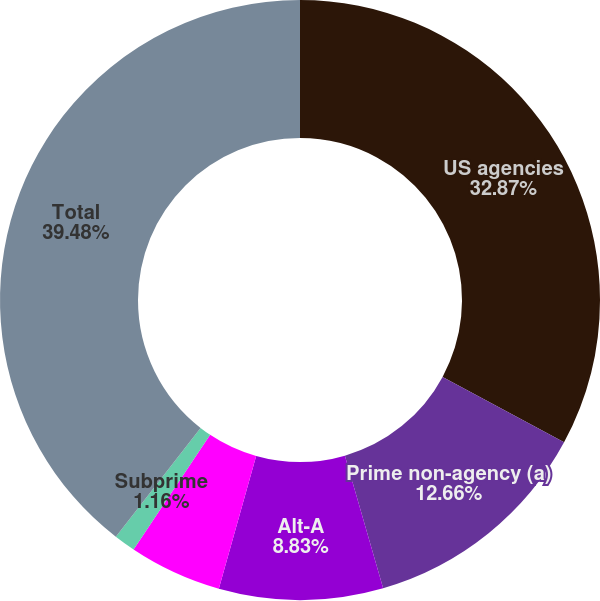Convert chart. <chart><loc_0><loc_0><loc_500><loc_500><pie_chart><fcel>US agencies<fcel>Prime non-agency (a)<fcel>Alt-A<fcel>Other housing-related (b)<fcel>Subprime<fcel>Total<nl><fcel>32.87%<fcel>12.66%<fcel>8.83%<fcel>5.0%<fcel>1.16%<fcel>39.48%<nl></chart> 